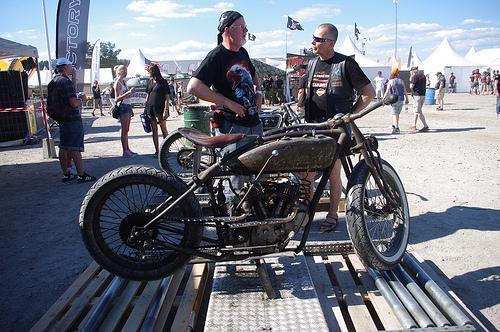How many men are by the bike?
Give a very brief answer. 2. How many motorcycles are shown?
Give a very brief answer. 1. 